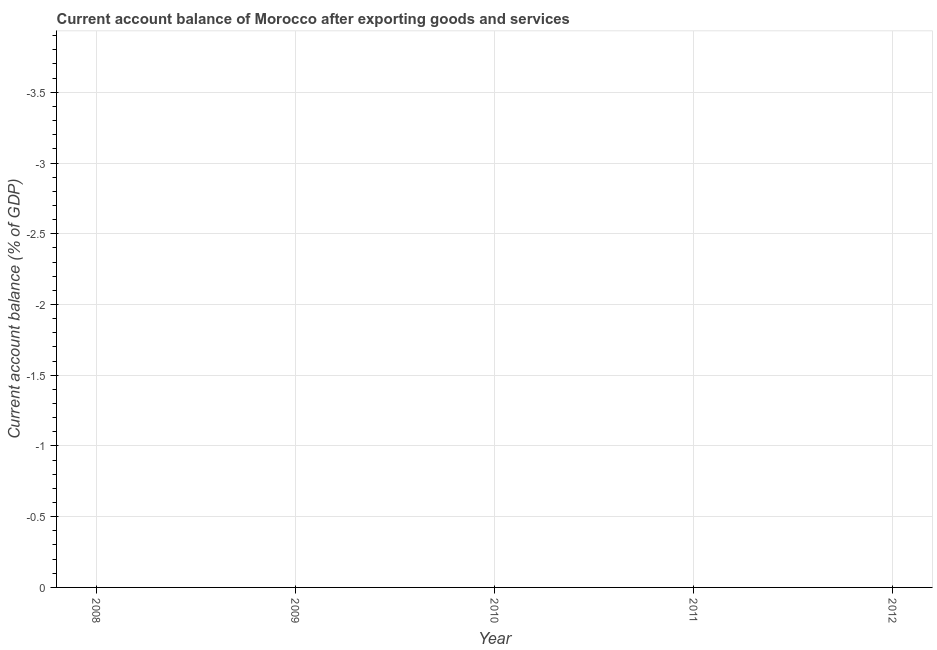What is the current account balance in 2008?
Your answer should be compact. 0. Across all years, what is the minimum current account balance?
Keep it short and to the point. 0. What is the sum of the current account balance?
Your answer should be very brief. 0. In how many years, is the current account balance greater than -3.1 %?
Provide a short and direct response. 0. Does the current account balance monotonically increase over the years?
Keep it short and to the point. No. How many dotlines are there?
Offer a terse response. 0. What is the difference between two consecutive major ticks on the Y-axis?
Give a very brief answer. 0.5. Does the graph contain any zero values?
Make the answer very short. Yes. What is the title of the graph?
Your answer should be compact. Current account balance of Morocco after exporting goods and services. What is the label or title of the Y-axis?
Give a very brief answer. Current account balance (% of GDP). What is the Current account balance (% of GDP) in 2008?
Your answer should be very brief. 0. What is the Current account balance (% of GDP) in 2009?
Keep it short and to the point. 0. What is the Current account balance (% of GDP) in 2010?
Provide a succinct answer. 0. What is the Current account balance (% of GDP) in 2012?
Provide a succinct answer. 0. 